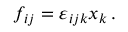<formula> <loc_0><loc_0><loc_500><loc_500>f _ { i j } = \varepsilon _ { i j k } x _ { k } \, .</formula> 